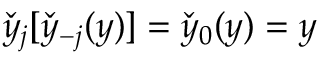Convert formula to latex. <formula><loc_0><loc_0><loc_500><loc_500>\check { y } _ { j } [ \check { y } _ { - j } ( y ) ] = \check { y } _ { 0 } ( y ) = y</formula> 